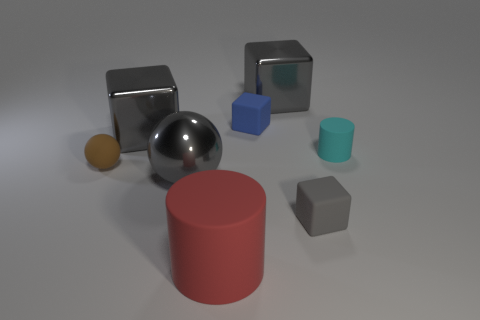Subtract all gray rubber blocks. How many blocks are left? 3 Subtract all purple cylinders. How many gray cubes are left? 3 Subtract all blue cubes. How many cubes are left? 3 Add 1 tiny brown shiny blocks. How many objects exist? 9 Subtract all green blocks. Subtract all blue spheres. How many blocks are left? 4 Subtract all balls. How many objects are left? 6 Subtract 0 green cylinders. How many objects are left? 8 Subtract all large blue spheres. Subtract all small blue cubes. How many objects are left? 7 Add 3 matte cubes. How many matte cubes are left? 5 Add 4 tiny metallic spheres. How many tiny metallic spheres exist? 4 